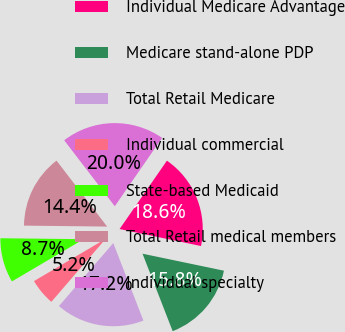<chart> <loc_0><loc_0><loc_500><loc_500><pie_chart><fcel>Individual Medicare Advantage<fcel>Medicare stand-alone PDP<fcel>Total Retail Medicare<fcel>Individual commercial<fcel>State-based Medicaid<fcel>Total Retail medical members<fcel>Individual specialty<nl><fcel>18.64%<fcel>15.82%<fcel>17.23%<fcel>5.2%<fcel>8.66%<fcel>14.4%<fcel>20.05%<nl></chart> 